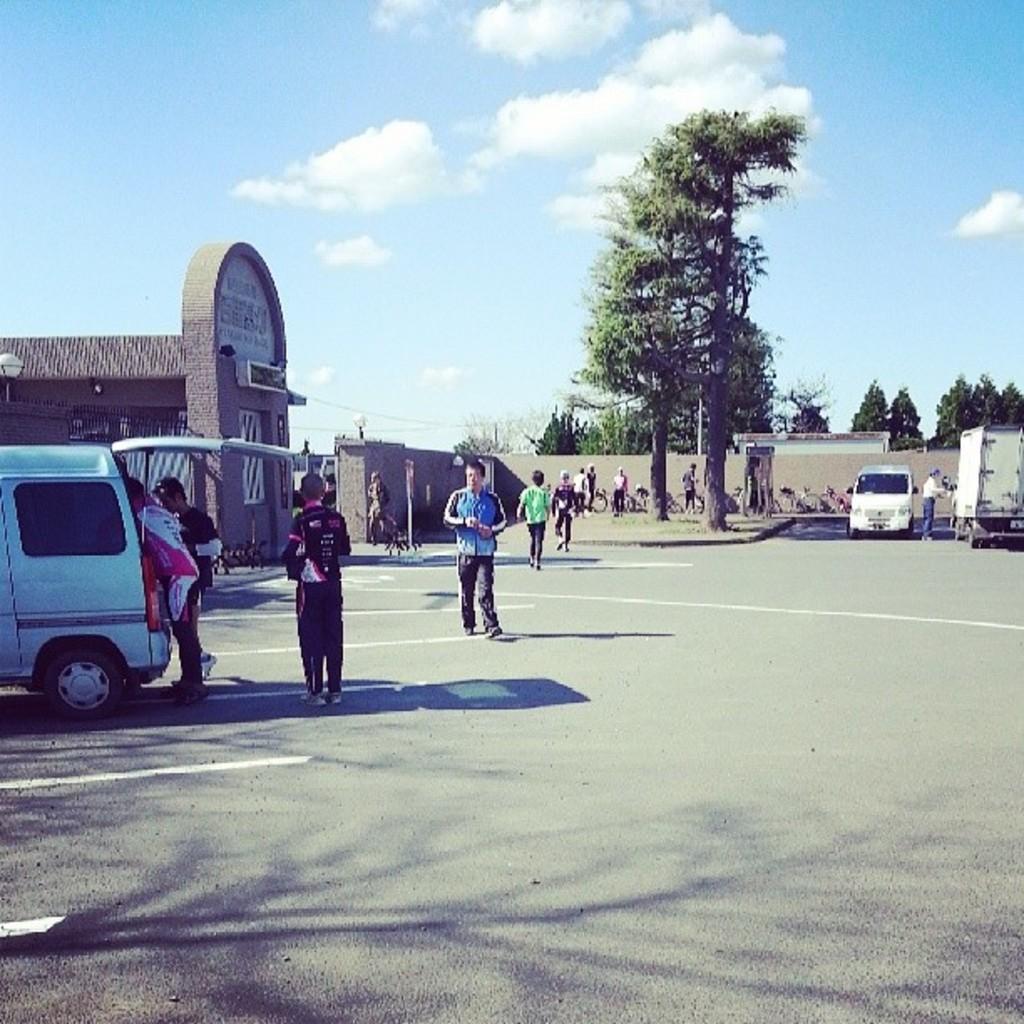In one or two sentences, can you explain what this image depicts? In the picture we can see a path to a part of a car and the back door is opened and we can see two people are standing and beside it, we can see a gate with compound wall inside the wall we can see some bicycles are parked near the wall and we can see a tree under it we can see a car and a van and behind the wall we can see trees and the sky with clouds. 